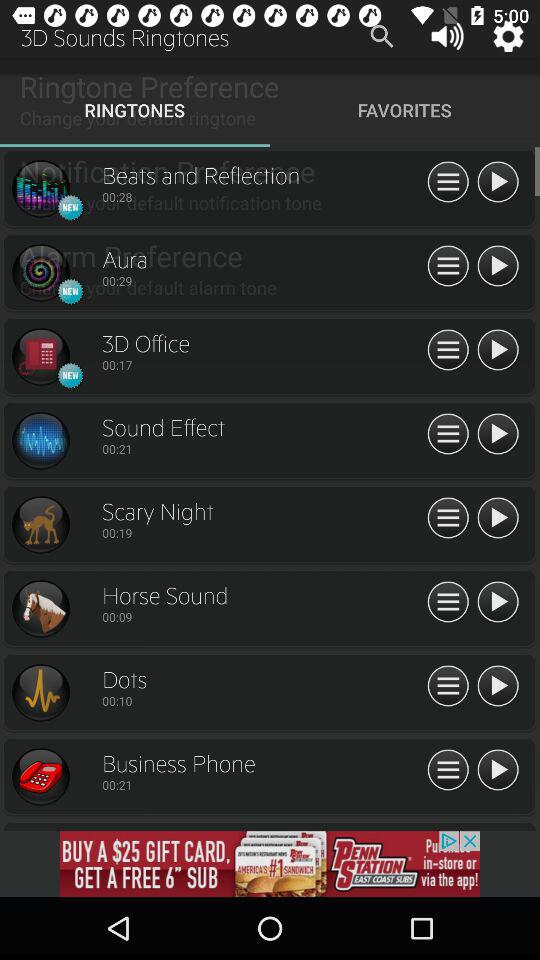What ringtone is playing? The playing ringtone is "Beats and Reflection". 